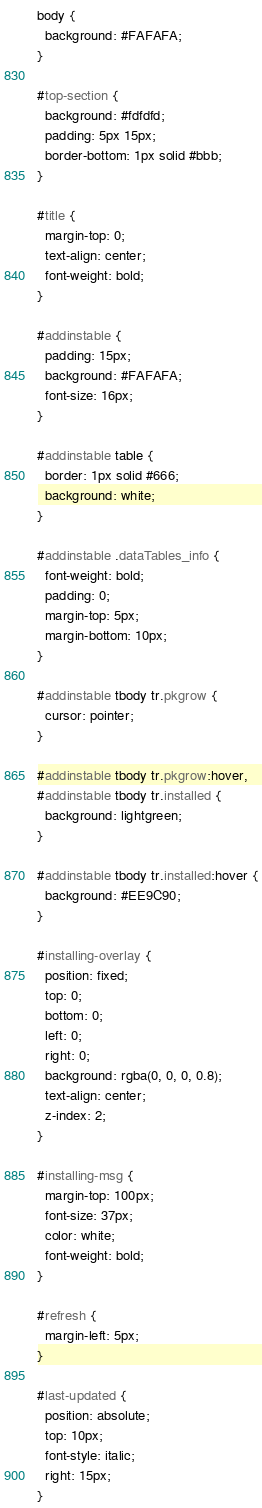Convert code to text. <code><loc_0><loc_0><loc_500><loc_500><_CSS_>body {
  background: #FAFAFA;
}

#top-section {
  background: #fdfdfd;
  padding: 5px 15px;
  border-bottom: 1px solid #bbb;
}

#title {
  margin-top: 0;
  text-align: center;
  font-weight: bold;
}

#addinstable {
  padding: 15px;
  background: #FAFAFA;
  font-size: 16px;
}

#addinstable table {
  border: 1px solid #666;
  background: white;
}

#addinstable .dataTables_info {
  font-weight: bold;
  padding: 0;
  margin-top: 5px;
  margin-bottom: 10px;
}

#addinstable tbody tr.pkgrow {
  cursor: pointer;
}

#addinstable tbody tr.pkgrow:hover,
#addinstable tbody tr.installed {
  background: lightgreen;
}

#addinstable tbody tr.installed:hover {
  background: #EE9C90;
}

#installing-overlay {
  position: fixed;
  top: 0;
  bottom: 0;
  left: 0;
  right: 0;
  background: rgba(0, 0, 0, 0.8);
  text-align: center;
  z-index: 2;
}

#installing-msg {
  margin-top: 100px;
  font-size: 37px;
  color: white;
  font-weight: bold;
}

#refresh {
  margin-left: 5px;
}

#last-updated {
  position: absolute;
  top: 10px;
  font-style: italic;
  right: 15px;
}</code> 